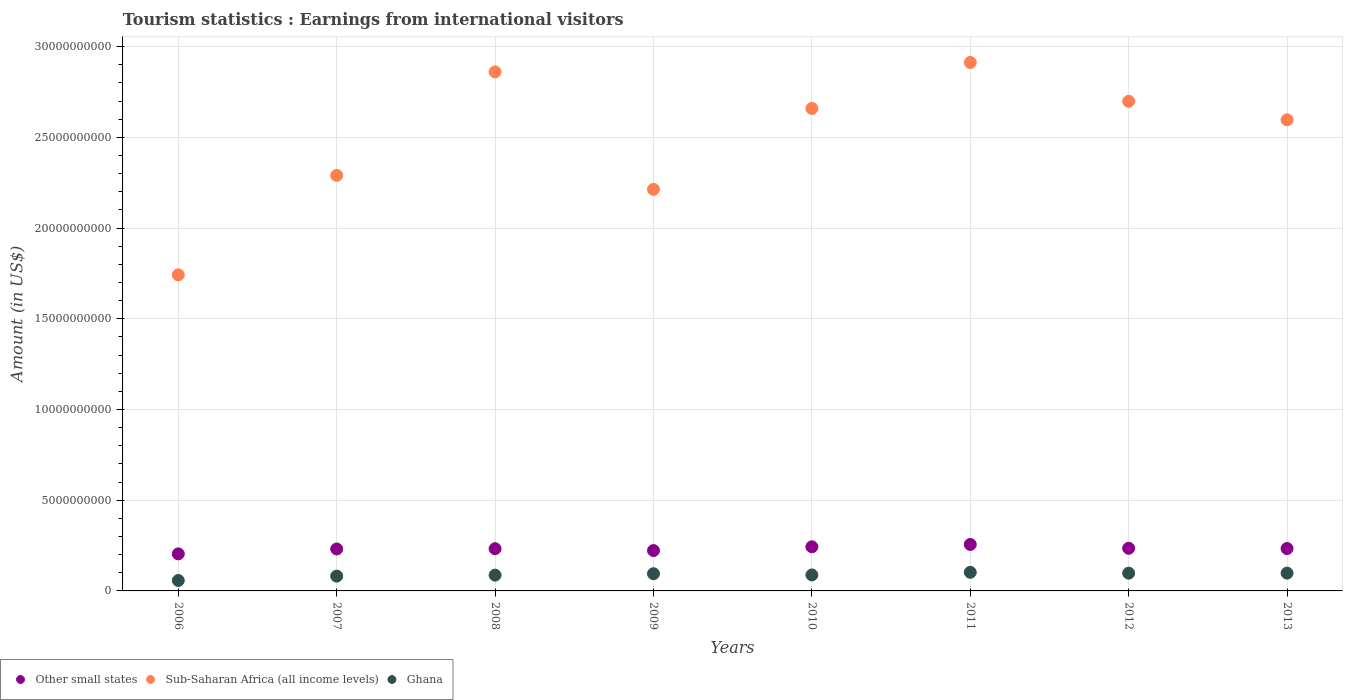How many different coloured dotlines are there?
Offer a very short reply. 3. What is the earnings from international visitors in Other small states in 2008?
Offer a very short reply. 2.33e+09. Across all years, what is the maximum earnings from international visitors in Other small states?
Give a very brief answer. 2.56e+09. Across all years, what is the minimum earnings from international visitors in Other small states?
Give a very brief answer. 2.04e+09. What is the total earnings from international visitors in Ghana in the graph?
Keep it short and to the point. 7.08e+09. What is the difference between the earnings from international visitors in Other small states in 2011 and that in 2013?
Offer a very short reply. 2.23e+08. What is the difference between the earnings from international visitors in Sub-Saharan Africa (all income levels) in 2011 and the earnings from international visitors in Ghana in 2012?
Give a very brief answer. 2.81e+1. What is the average earnings from international visitors in Ghana per year?
Make the answer very short. 8.85e+08. In the year 2012, what is the difference between the earnings from international visitors in Sub-Saharan Africa (all income levels) and earnings from international visitors in Other small states?
Keep it short and to the point. 2.46e+1. What is the ratio of the earnings from international visitors in Sub-Saharan Africa (all income levels) in 2006 to that in 2010?
Your response must be concise. 0.66. Is the difference between the earnings from international visitors in Sub-Saharan Africa (all income levels) in 2007 and 2009 greater than the difference between the earnings from international visitors in Other small states in 2007 and 2009?
Your response must be concise. Yes. What is the difference between the highest and the second highest earnings from international visitors in Other small states?
Provide a short and direct response. 1.28e+08. What is the difference between the highest and the lowest earnings from international visitors in Other small states?
Your response must be concise. 5.18e+08. In how many years, is the earnings from international visitors in Ghana greater than the average earnings from international visitors in Ghana taken over all years?
Your answer should be very brief. 4. Is the sum of the earnings from international visitors in Ghana in 2007 and 2010 greater than the maximum earnings from international visitors in Other small states across all years?
Your answer should be very brief. No. Does the earnings from international visitors in Other small states monotonically increase over the years?
Your answer should be compact. No. Is the earnings from international visitors in Other small states strictly less than the earnings from international visitors in Ghana over the years?
Your answer should be compact. No. How many dotlines are there?
Keep it short and to the point. 3. What is the difference between two consecutive major ticks on the Y-axis?
Your response must be concise. 5.00e+09. Are the values on the major ticks of Y-axis written in scientific E-notation?
Your response must be concise. No. Where does the legend appear in the graph?
Keep it short and to the point. Bottom left. What is the title of the graph?
Offer a terse response. Tourism statistics : Earnings from international visitors. What is the Amount (in US$) in Other small states in 2006?
Provide a short and direct response. 2.04e+09. What is the Amount (in US$) of Sub-Saharan Africa (all income levels) in 2006?
Your answer should be very brief. 1.74e+1. What is the Amount (in US$) in Ghana in 2006?
Your answer should be very brief. 5.75e+08. What is the Amount (in US$) of Other small states in 2007?
Ensure brevity in your answer.  2.31e+09. What is the Amount (in US$) of Sub-Saharan Africa (all income levels) in 2007?
Keep it short and to the point. 2.29e+1. What is the Amount (in US$) of Ghana in 2007?
Make the answer very short. 8.16e+08. What is the Amount (in US$) in Other small states in 2008?
Your response must be concise. 2.33e+09. What is the Amount (in US$) in Sub-Saharan Africa (all income levels) in 2008?
Make the answer very short. 2.86e+1. What is the Amount (in US$) of Ghana in 2008?
Offer a very short reply. 8.70e+08. What is the Amount (in US$) in Other small states in 2009?
Ensure brevity in your answer.  2.23e+09. What is the Amount (in US$) of Sub-Saharan Africa (all income levels) in 2009?
Make the answer very short. 2.21e+1. What is the Amount (in US$) in Ghana in 2009?
Your answer should be compact. 9.48e+08. What is the Amount (in US$) in Other small states in 2010?
Offer a terse response. 2.43e+09. What is the Amount (in US$) of Sub-Saharan Africa (all income levels) in 2010?
Ensure brevity in your answer.  2.66e+1. What is the Amount (in US$) of Ghana in 2010?
Provide a short and direct response. 8.82e+08. What is the Amount (in US$) in Other small states in 2011?
Your answer should be very brief. 2.56e+09. What is the Amount (in US$) in Sub-Saharan Africa (all income levels) in 2011?
Your answer should be compact. 2.91e+1. What is the Amount (in US$) of Ghana in 2011?
Ensure brevity in your answer.  1.03e+09. What is the Amount (in US$) in Other small states in 2012?
Keep it short and to the point. 2.35e+09. What is the Amount (in US$) of Sub-Saharan Africa (all income levels) in 2012?
Your answer should be very brief. 2.70e+1. What is the Amount (in US$) in Ghana in 2012?
Your answer should be compact. 9.79e+08. What is the Amount (in US$) in Other small states in 2013?
Offer a terse response. 2.34e+09. What is the Amount (in US$) in Sub-Saharan Africa (all income levels) in 2013?
Make the answer very short. 2.60e+1. What is the Amount (in US$) in Ghana in 2013?
Provide a succinct answer. 9.82e+08. Across all years, what is the maximum Amount (in US$) in Other small states?
Provide a short and direct response. 2.56e+09. Across all years, what is the maximum Amount (in US$) in Sub-Saharan Africa (all income levels)?
Provide a succinct answer. 2.91e+1. Across all years, what is the maximum Amount (in US$) in Ghana?
Make the answer very short. 1.03e+09. Across all years, what is the minimum Amount (in US$) of Other small states?
Make the answer very short. 2.04e+09. Across all years, what is the minimum Amount (in US$) in Sub-Saharan Africa (all income levels)?
Provide a succinct answer. 1.74e+1. Across all years, what is the minimum Amount (in US$) of Ghana?
Provide a short and direct response. 5.75e+08. What is the total Amount (in US$) in Other small states in the graph?
Your answer should be compact. 1.86e+1. What is the total Amount (in US$) in Sub-Saharan Africa (all income levels) in the graph?
Provide a short and direct response. 2.00e+11. What is the total Amount (in US$) of Ghana in the graph?
Provide a short and direct response. 7.08e+09. What is the difference between the Amount (in US$) in Other small states in 2006 and that in 2007?
Make the answer very short. -2.69e+08. What is the difference between the Amount (in US$) of Sub-Saharan Africa (all income levels) in 2006 and that in 2007?
Your answer should be very brief. -5.48e+09. What is the difference between the Amount (in US$) of Ghana in 2006 and that in 2007?
Provide a short and direct response. -2.41e+08. What is the difference between the Amount (in US$) of Other small states in 2006 and that in 2008?
Offer a very short reply. -2.86e+08. What is the difference between the Amount (in US$) of Sub-Saharan Africa (all income levels) in 2006 and that in 2008?
Give a very brief answer. -1.12e+1. What is the difference between the Amount (in US$) in Ghana in 2006 and that in 2008?
Offer a terse response. -2.95e+08. What is the difference between the Amount (in US$) of Other small states in 2006 and that in 2009?
Offer a terse response. -1.83e+08. What is the difference between the Amount (in US$) in Sub-Saharan Africa (all income levels) in 2006 and that in 2009?
Your answer should be compact. -4.71e+09. What is the difference between the Amount (in US$) in Ghana in 2006 and that in 2009?
Offer a very short reply. -3.73e+08. What is the difference between the Amount (in US$) of Other small states in 2006 and that in 2010?
Make the answer very short. -3.91e+08. What is the difference between the Amount (in US$) in Sub-Saharan Africa (all income levels) in 2006 and that in 2010?
Your response must be concise. -9.17e+09. What is the difference between the Amount (in US$) of Ghana in 2006 and that in 2010?
Make the answer very short. -3.07e+08. What is the difference between the Amount (in US$) in Other small states in 2006 and that in 2011?
Make the answer very short. -5.18e+08. What is the difference between the Amount (in US$) of Sub-Saharan Africa (all income levels) in 2006 and that in 2011?
Keep it short and to the point. -1.17e+1. What is the difference between the Amount (in US$) of Ghana in 2006 and that in 2011?
Ensure brevity in your answer.  -4.51e+08. What is the difference between the Amount (in US$) in Other small states in 2006 and that in 2012?
Your answer should be very brief. -3.08e+08. What is the difference between the Amount (in US$) of Sub-Saharan Africa (all income levels) in 2006 and that in 2012?
Keep it short and to the point. -9.57e+09. What is the difference between the Amount (in US$) in Ghana in 2006 and that in 2012?
Your answer should be compact. -4.04e+08. What is the difference between the Amount (in US$) of Other small states in 2006 and that in 2013?
Give a very brief answer. -2.95e+08. What is the difference between the Amount (in US$) of Sub-Saharan Africa (all income levels) in 2006 and that in 2013?
Ensure brevity in your answer.  -8.54e+09. What is the difference between the Amount (in US$) of Ghana in 2006 and that in 2013?
Provide a short and direct response. -4.07e+08. What is the difference between the Amount (in US$) in Other small states in 2007 and that in 2008?
Make the answer very short. -1.67e+07. What is the difference between the Amount (in US$) in Sub-Saharan Africa (all income levels) in 2007 and that in 2008?
Your answer should be compact. -5.71e+09. What is the difference between the Amount (in US$) in Ghana in 2007 and that in 2008?
Offer a terse response. -5.40e+07. What is the difference between the Amount (in US$) of Other small states in 2007 and that in 2009?
Your answer should be very brief. 8.64e+07. What is the difference between the Amount (in US$) in Sub-Saharan Africa (all income levels) in 2007 and that in 2009?
Keep it short and to the point. 7.64e+08. What is the difference between the Amount (in US$) of Ghana in 2007 and that in 2009?
Offer a very short reply. -1.32e+08. What is the difference between the Amount (in US$) in Other small states in 2007 and that in 2010?
Make the answer very short. -1.21e+08. What is the difference between the Amount (in US$) of Sub-Saharan Africa (all income levels) in 2007 and that in 2010?
Provide a succinct answer. -3.69e+09. What is the difference between the Amount (in US$) of Ghana in 2007 and that in 2010?
Ensure brevity in your answer.  -6.60e+07. What is the difference between the Amount (in US$) in Other small states in 2007 and that in 2011?
Provide a short and direct response. -2.49e+08. What is the difference between the Amount (in US$) in Sub-Saharan Africa (all income levels) in 2007 and that in 2011?
Your answer should be compact. -6.23e+09. What is the difference between the Amount (in US$) of Ghana in 2007 and that in 2011?
Offer a very short reply. -2.10e+08. What is the difference between the Amount (in US$) of Other small states in 2007 and that in 2012?
Your answer should be compact. -3.88e+07. What is the difference between the Amount (in US$) in Sub-Saharan Africa (all income levels) in 2007 and that in 2012?
Make the answer very short. -4.09e+09. What is the difference between the Amount (in US$) in Ghana in 2007 and that in 2012?
Offer a very short reply. -1.63e+08. What is the difference between the Amount (in US$) of Other small states in 2007 and that in 2013?
Keep it short and to the point. -2.57e+07. What is the difference between the Amount (in US$) of Sub-Saharan Africa (all income levels) in 2007 and that in 2013?
Ensure brevity in your answer.  -3.07e+09. What is the difference between the Amount (in US$) of Ghana in 2007 and that in 2013?
Offer a terse response. -1.66e+08. What is the difference between the Amount (in US$) in Other small states in 2008 and that in 2009?
Keep it short and to the point. 1.03e+08. What is the difference between the Amount (in US$) of Sub-Saharan Africa (all income levels) in 2008 and that in 2009?
Provide a succinct answer. 6.47e+09. What is the difference between the Amount (in US$) in Ghana in 2008 and that in 2009?
Your response must be concise. -7.80e+07. What is the difference between the Amount (in US$) in Other small states in 2008 and that in 2010?
Your answer should be compact. -1.05e+08. What is the difference between the Amount (in US$) in Sub-Saharan Africa (all income levels) in 2008 and that in 2010?
Keep it short and to the point. 2.02e+09. What is the difference between the Amount (in US$) in Ghana in 2008 and that in 2010?
Offer a very short reply. -1.20e+07. What is the difference between the Amount (in US$) of Other small states in 2008 and that in 2011?
Offer a terse response. -2.32e+08. What is the difference between the Amount (in US$) in Sub-Saharan Africa (all income levels) in 2008 and that in 2011?
Your answer should be compact. -5.19e+08. What is the difference between the Amount (in US$) in Ghana in 2008 and that in 2011?
Provide a short and direct response. -1.56e+08. What is the difference between the Amount (in US$) of Other small states in 2008 and that in 2012?
Your response must be concise. -2.21e+07. What is the difference between the Amount (in US$) of Sub-Saharan Africa (all income levels) in 2008 and that in 2012?
Provide a short and direct response. 1.62e+09. What is the difference between the Amount (in US$) of Ghana in 2008 and that in 2012?
Your answer should be compact. -1.09e+08. What is the difference between the Amount (in US$) in Other small states in 2008 and that in 2013?
Make the answer very short. -9.03e+06. What is the difference between the Amount (in US$) of Sub-Saharan Africa (all income levels) in 2008 and that in 2013?
Provide a short and direct response. 2.64e+09. What is the difference between the Amount (in US$) of Ghana in 2008 and that in 2013?
Provide a short and direct response. -1.12e+08. What is the difference between the Amount (in US$) of Other small states in 2009 and that in 2010?
Offer a very short reply. -2.08e+08. What is the difference between the Amount (in US$) of Sub-Saharan Africa (all income levels) in 2009 and that in 2010?
Keep it short and to the point. -4.45e+09. What is the difference between the Amount (in US$) of Ghana in 2009 and that in 2010?
Offer a terse response. 6.60e+07. What is the difference between the Amount (in US$) of Other small states in 2009 and that in 2011?
Your response must be concise. -3.35e+08. What is the difference between the Amount (in US$) of Sub-Saharan Africa (all income levels) in 2009 and that in 2011?
Ensure brevity in your answer.  -6.99e+09. What is the difference between the Amount (in US$) of Ghana in 2009 and that in 2011?
Keep it short and to the point. -7.80e+07. What is the difference between the Amount (in US$) of Other small states in 2009 and that in 2012?
Give a very brief answer. -1.25e+08. What is the difference between the Amount (in US$) in Sub-Saharan Africa (all income levels) in 2009 and that in 2012?
Ensure brevity in your answer.  -4.85e+09. What is the difference between the Amount (in US$) in Ghana in 2009 and that in 2012?
Your answer should be very brief. -3.10e+07. What is the difference between the Amount (in US$) of Other small states in 2009 and that in 2013?
Provide a succinct answer. -1.12e+08. What is the difference between the Amount (in US$) of Sub-Saharan Africa (all income levels) in 2009 and that in 2013?
Give a very brief answer. -3.83e+09. What is the difference between the Amount (in US$) of Ghana in 2009 and that in 2013?
Your answer should be very brief. -3.40e+07. What is the difference between the Amount (in US$) of Other small states in 2010 and that in 2011?
Your answer should be compact. -1.28e+08. What is the difference between the Amount (in US$) in Sub-Saharan Africa (all income levels) in 2010 and that in 2011?
Offer a very short reply. -2.54e+09. What is the difference between the Amount (in US$) in Ghana in 2010 and that in 2011?
Give a very brief answer. -1.44e+08. What is the difference between the Amount (in US$) of Other small states in 2010 and that in 2012?
Offer a terse response. 8.26e+07. What is the difference between the Amount (in US$) in Sub-Saharan Africa (all income levels) in 2010 and that in 2012?
Offer a very short reply. -3.97e+08. What is the difference between the Amount (in US$) of Ghana in 2010 and that in 2012?
Provide a short and direct response. -9.70e+07. What is the difference between the Amount (in US$) in Other small states in 2010 and that in 2013?
Keep it short and to the point. 9.57e+07. What is the difference between the Amount (in US$) of Sub-Saharan Africa (all income levels) in 2010 and that in 2013?
Provide a succinct answer. 6.25e+08. What is the difference between the Amount (in US$) in Ghana in 2010 and that in 2013?
Provide a short and direct response. -1.00e+08. What is the difference between the Amount (in US$) of Other small states in 2011 and that in 2012?
Provide a succinct answer. 2.10e+08. What is the difference between the Amount (in US$) in Sub-Saharan Africa (all income levels) in 2011 and that in 2012?
Your response must be concise. 2.14e+09. What is the difference between the Amount (in US$) of Ghana in 2011 and that in 2012?
Your answer should be very brief. 4.70e+07. What is the difference between the Amount (in US$) in Other small states in 2011 and that in 2013?
Offer a very short reply. 2.23e+08. What is the difference between the Amount (in US$) in Sub-Saharan Africa (all income levels) in 2011 and that in 2013?
Offer a very short reply. 3.16e+09. What is the difference between the Amount (in US$) in Ghana in 2011 and that in 2013?
Your response must be concise. 4.40e+07. What is the difference between the Amount (in US$) in Other small states in 2012 and that in 2013?
Offer a terse response. 1.31e+07. What is the difference between the Amount (in US$) of Sub-Saharan Africa (all income levels) in 2012 and that in 2013?
Give a very brief answer. 1.02e+09. What is the difference between the Amount (in US$) in Ghana in 2012 and that in 2013?
Your answer should be compact. -3.00e+06. What is the difference between the Amount (in US$) of Other small states in 2006 and the Amount (in US$) of Sub-Saharan Africa (all income levels) in 2007?
Offer a very short reply. -2.09e+1. What is the difference between the Amount (in US$) of Other small states in 2006 and the Amount (in US$) of Ghana in 2007?
Provide a short and direct response. 1.23e+09. What is the difference between the Amount (in US$) in Sub-Saharan Africa (all income levels) in 2006 and the Amount (in US$) in Ghana in 2007?
Offer a very short reply. 1.66e+1. What is the difference between the Amount (in US$) of Other small states in 2006 and the Amount (in US$) of Sub-Saharan Africa (all income levels) in 2008?
Your response must be concise. -2.66e+1. What is the difference between the Amount (in US$) of Other small states in 2006 and the Amount (in US$) of Ghana in 2008?
Give a very brief answer. 1.17e+09. What is the difference between the Amount (in US$) in Sub-Saharan Africa (all income levels) in 2006 and the Amount (in US$) in Ghana in 2008?
Your response must be concise. 1.66e+1. What is the difference between the Amount (in US$) in Other small states in 2006 and the Amount (in US$) in Sub-Saharan Africa (all income levels) in 2009?
Your response must be concise. -2.01e+1. What is the difference between the Amount (in US$) in Other small states in 2006 and the Amount (in US$) in Ghana in 2009?
Make the answer very short. 1.09e+09. What is the difference between the Amount (in US$) of Sub-Saharan Africa (all income levels) in 2006 and the Amount (in US$) of Ghana in 2009?
Make the answer very short. 1.65e+1. What is the difference between the Amount (in US$) of Other small states in 2006 and the Amount (in US$) of Sub-Saharan Africa (all income levels) in 2010?
Your answer should be very brief. -2.45e+1. What is the difference between the Amount (in US$) in Other small states in 2006 and the Amount (in US$) in Ghana in 2010?
Your answer should be compact. 1.16e+09. What is the difference between the Amount (in US$) of Sub-Saharan Africa (all income levels) in 2006 and the Amount (in US$) of Ghana in 2010?
Your response must be concise. 1.65e+1. What is the difference between the Amount (in US$) of Other small states in 2006 and the Amount (in US$) of Sub-Saharan Africa (all income levels) in 2011?
Ensure brevity in your answer.  -2.71e+1. What is the difference between the Amount (in US$) in Other small states in 2006 and the Amount (in US$) in Ghana in 2011?
Your answer should be very brief. 1.02e+09. What is the difference between the Amount (in US$) of Sub-Saharan Africa (all income levels) in 2006 and the Amount (in US$) of Ghana in 2011?
Make the answer very short. 1.64e+1. What is the difference between the Amount (in US$) of Other small states in 2006 and the Amount (in US$) of Sub-Saharan Africa (all income levels) in 2012?
Give a very brief answer. -2.49e+1. What is the difference between the Amount (in US$) of Other small states in 2006 and the Amount (in US$) of Ghana in 2012?
Ensure brevity in your answer.  1.06e+09. What is the difference between the Amount (in US$) in Sub-Saharan Africa (all income levels) in 2006 and the Amount (in US$) in Ghana in 2012?
Make the answer very short. 1.64e+1. What is the difference between the Amount (in US$) of Other small states in 2006 and the Amount (in US$) of Sub-Saharan Africa (all income levels) in 2013?
Your response must be concise. -2.39e+1. What is the difference between the Amount (in US$) in Other small states in 2006 and the Amount (in US$) in Ghana in 2013?
Your response must be concise. 1.06e+09. What is the difference between the Amount (in US$) of Sub-Saharan Africa (all income levels) in 2006 and the Amount (in US$) of Ghana in 2013?
Your answer should be compact. 1.64e+1. What is the difference between the Amount (in US$) of Other small states in 2007 and the Amount (in US$) of Sub-Saharan Africa (all income levels) in 2008?
Make the answer very short. -2.63e+1. What is the difference between the Amount (in US$) of Other small states in 2007 and the Amount (in US$) of Ghana in 2008?
Your answer should be compact. 1.44e+09. What is the difference between the Amount (in US$) of Sub-Saharan Africa (all income levels) in 2007 and the Amount (in US$) of Ghana in 2008?
Offer a very short reply. 2.20e+1. What is the difference between the Amount (in US$) in Other small states in 2007 and the Amount (in US$) in Sub-Saharan Africa (all income levels) in 2009?
Your answer should be very brief. -1.98e+1. What is the difference between the Amount (in US$) in Other small states in 2007 and the Amount (in US$) in Ghana in 2009?
Your answer should be very brief. 1.36e+09. What is the difference between the Amount (in US$) in Sub-Saharan Africa (all income levels) in 2007 and the Amount (in US$) in Ghana in 2009?
Offer a very short reply. 2.20e+1. What is the difference between the Amount (in US$) in Other small states in 2007 and the Amount (in US$) in Sub-Saharan Africa (all income levels) in 2010?
Your answer should be compact. -2.43e+1. What is the difference between the Amount (in US$) of Other small states in 2007 and the Amount (in US$) of Ghana in 2010?
Offer a very short reply. 1.43e+09. What is the difference between the Amount (in US$) of Sub-Saharan Africa (all income levels) in 2007 and the Amount (in US$) of Ghana in 2010?
Provide a short and direct response. 2.20e+1. What is the difference between the Amount (in US$) of Other small states in 2007 and the Amount (in US$) of Sub-Saharan Africa (all income levels) in 2011?
Provide a short and direct response. -2.68e+1. What is the difference between the Amount (in US$) in Other small states in 2007 and the Amount (in US$) in Ghana in 2011?
Your answer should be compact. 1.29e+09. What is the difference between the Amount (in US$) in Sub-Saharan Africa (all income levels) in 2007 and the Amount (in US$) in Ghana in 2011?
Your response must be concise. 2.19e+1. What is the difference between the Amount (in US$) of Other small states in 2007 and the Amount (in US$) of Sub-Saharan Africa (all income levels) in 2012?
Provide a short and direct response. -2.47e+1. What is the difference between the Amount (in US$) in Other small states in 2007 and the Amount (in US$) in Ghana in 2012?
Offer a very short reply. 1.33e+09. What is the difference between the Amount (in US$) of Sub-Saharan Africa (all income levels) in 2007 and the Amount (in US$) of Ghana in 2012?
Offer a terse response. 2.19e+1. What is the difference between the Amount (in US$) of Other small states in 2007 and the Amount (in US$) of Sub-Saharan Africa (all income levels) in 2013?
Your answer should be compact. -2.37e+1. What is the difference between the Amount (in US$) in Other small states in 2007 and the Amount (in US$) in Ghana in 2013?
Keep it short and to the point. 1.33e+09. What is the difference between the Amount (in US$) of Sub-Saharan Africa (all income levels) in 2007 and the Amount (in US$) of Ghana in 2013?
Make the answer very short. 2.19e+1. What is the difference between the Amount (in US$) in Other small states in 2008 and the Amount (in US$) in Sub-Saharan Africa (all income levels) in 2009?
Provide a succinct answer. -1.98e+1. What is the difference between the Amount (in US$) in Other small states in 2008 and the Amount (in US$) in Ghana in 2009?
Make the answer very short. 1.38e+09. What is the difference between the Amount (in US$) in Sub-Saharan Africa (all income levels) in 2008 and the Amount (in US$) in Ghana in 2009?
Your response must be concise. 2.77e+1. What is the difference between the Amount (in US$) of Other small states in 2008 and the Amount (in US$) of Sub-Saharan Africa (all income levels) in 2010?
Give a very brief answer. -2.43e+1. What is the difference between the Amount (in US$) of Other small states in 2008 and the Amount (in US$) of Ghana in 2010?
Make the answer very short. 1.45e+09. What is the difference between the Amount (in US$) of Sub-Saharan Africa (all income levels) in 2008 and the Amount (in US$) of Ghana in 2010?
Make the answer very short. 2.77e+1. What is the difference between the Amount (in US$) in Other small states in 2008 and the Amount (in US$) in Sub-Saharan Africa (all income levels) in 2011?
Offer a very short reply. -2.68e+1. What is the difference between the Amount (in US$) of Other small states in 2008 and the Amount (in US$) of Ghana in 2011?
Provide a short and direct response. 1.30e+09. What is the difference between the Amount (in US$) in Sub-Saharan Africa (all income levels) in 2008 and the Amount (in US$) in Ghana in 2011?
Provide a succinct answer. 2.76e+1. What is the difference between the Amount (in US$) of Other small states in 2008 and the Amount (in US$) of Sub-Saharan Africa (all income levels) in 2012?
Offer a very short reply. -2.47e+1. What is the difference between the Amount (in US$) in Other small states in 2008 and the Amount (in US$) in Ghana in 2012?
Your response must be concise. 1.35e+09. What is the difference between the Amount (in US$) of Sub-Saharan Africa (all income levels) in 2008 and the Amount (in US$) of Ghana in 2012?
Your answer should be compact. 2.76e+1. What is the difference between the Amount (in US$) in Other small states in 2008 and the Amount (in US$) in Sub-Saharan Africa (all income levels) in 2013?
Offer a terse response. -2.36e+1. What is the difference between the Amount (in US$) of Other small states in 2008 and the Amount (in US$) of Ghana in 2013?
Provide a short and direct response. 1.35e+09. What is the difference between the Amount (in US$) of Sub-Saharan Africa (all income levels) in 2008 and the Amount (in US$) of Ghana in 2013?
Your response must be concise. 2.76e+1. What is the difference between the Amount (in US$) of Other small states in 2009 and the Amount (in US$) of Sub-Saharan Africa (all income levels) in 2010?
Your answer should be compact. -2.44e+1. What is the difference between the Amount (in US$) of Other small states in 2009 and the Amount (in US$) of Ghana in 2010?
Make the answer very short. 1.34e+09. What is the difference between the Amount (in US$) in Sub-Saharan Africa (all income levels) in 2009 and the Amount (in US$) in Ghana in 2010?
Provide a short and direct response. 2.13e+1. What is the difference between the Amount (in US$) in Other small states in 2009 and the Amount (in US$) in Sub-Saharan Africa (all income levels) in 2011?
Keep it short and to the point. -2.69e+1. What is the difference between the Amount (in US$) of Other small states in 2009 and the Amount (in US$) of Ghana in 2011?
Make the answer very short. 1.20e+09. What is the difference between the Amount (in US$) in Sub-Saharan Africa (all income levels) in 2009 and the Amount (in US$) in Ghana in 2011?
Keep it short and to the point. 2.11e+1. What is the difference between the Amount (in US$) of Other small states in 2009 and the Amount (in US$) of Sub-Saharan Africa (all income levels) in 2012?
Your answer should be compact. -2.48e+1. What is the difference between the Amount (in US$) in Other small states in 2009 and the Amount (in US$) in Ghana in 2012?
Give a very brief answer. 1.25e+09. What is the difference between the Amount (in US$) of Sub-Saharan Africa (all income levels) in 2009 and the Amount (in US$) of Ghana in 2012?
Your response must be concise. 2.12e+1. What is the difference between the Amount (in US$) in Other small states in 2009 and the Amount (in US$) in Sub-Saharan Africa (all income levels) in 2013?
Provide a short and direct response. -2.37e+1. What is the difference between the Amount (in US$) in Other small states in 2009 and the Amount (in US$) in Ghana in 2013?
Give a very brief answer. 1.24e+09. What is the difference between the Amount (in US$) of Sub-Saharan Africa (all income levels) in 2009 and the Amount (in US$) of Ghana in 2013?
Your response must be concise. 2.12e+1. What is the difference between the Amount (in US$) in Other small states in 2010 and the Amount (in US$) in Sub-Saharan Africa (all income levels) in 2011?
Offer a terse response. -2.67e+1. What is the difference between the Amount (in US$) in Other small states in 2010 and the Amount (in US$) in Ghana in 2011?
Give a very brief answer. 1.41e+09. What is the difference between the Amount (in US$) in Sub-Saharan Africa (all income levels) in 2010 and the Amount (in US$) in Ghana in 2011?
Give a very brief answer. 2.56e+1. What is the difference between the Amount (in US$) in Other small states in 2010 and the Amount (in US$) in Sub-Saharan Africa (all income levels) in 2012?
Keep it short and to the point. -2.46e+1. What is the difference between the Amount (in US$) in Other small states in 2010 and the Amount (in US$) in Ghana in 2012?
Offer a terse response. 1.45e+09. What is the difference between the Amount (in US$) of Sub-Saharan Africa (all income levels) in 2010 and the Amount (in US$) of Ghana in 2012?
Provide a short and direct response. 2.56e+1. What is the difference between the Amount (in US$) of Other small states in 2010 and the Amount (in US$) of Sub-Saharan Africa (all income levels) in 2013?
Offer a terse response. -2.35e+1. What is the difference between the Amount (in US$) in Other small states in 2010 and the Amount (in US$) in Ghana in 2013?
Your response must be concise. 1.45e+09. What is the difference between the Amount (in US$) of Sub-Saharan Africa (all income levels) in 2010 and the Amount (in US$) of Ghana in 2013?
Provide a short and direct response. 2.56e+1. What is the difference between the Amount (in US$) of Other small states in 2011 and the Amount (in US$) of Sub-Saharan Africa (all income levels) in 2012?
Offer a terse response. -2.44e+1. What is the difference between the Amount (in US$) in Other small states in 2011 and the Amount (in US$) in Ghana in 2012?
Your response must be concise. 1.58e+09. What is the difference between the Amount (in US$) in Sub-Saharan Africa (all income levels) in 2011 and the Amount (in US$) in Ghana in 2012?
Offer a terse response. 2.81e+1. What is the difference between the Amount (in US$) in Other small states in 2011 and the Amount (in US$) in Sub-Saharan Africa (all income levels) in 2013?
Your answer should be very brief. -2.34e+1. What is the difference between the Amount (in US$) in Other small states in 2011 and the Amount (in US$) in Ghana in 2013?
Your answer should be very brief. 1.58e+09. What is the difference between the Amount (in US$) in Sub-Saharan Africa (all income levels) in 2011 and the Amount (in US$) in Ghana in 2013?
Offer a terse response. 2.81e+1. What is the difference between the Amount (in US$) of Other small states in 2012 and the Amount (in US$) of Sub-Saharan Africa (all income levels) in 2013?
Provide a short and direct response. -2.36e+1. What is the difference between the Amount (in US$) in Other small states in 2012 and the Amount (in US$) in Ghana in 2013?
Offer a terse response. 1.37e+09. What is the difference between the Amount (in US$) of Sub-Saharan Africa (all income levels) in 2012 and the Amount (in US$) of Ghana in 2013?
Provide a succinct answer. 2.60e+1. What is the average Amount (in US$) in Other small states per year?
Offer a terse response. 2.32e+09. What is the average Amount (in US$) of Sub-Saharan Africa (all income levels) per year?
Your response must be concise. 2.50e+1. What is the average Amount (in US$) of Ghana per year?
Offer a terse response. 8.85e+08. In the year 2006, what is the difference between the Amount (in US$) in Other small states and Amount (in US$) in Sub-Saharan Africa (all income levels)?
Your answer should be very brief. -1.54e+1. In the year 2006, what is the difference between the Amount (in US$) in Other small states and Amount (in US$) in Ghana?
Offer a very short reply. 1.47e+09. In the year 2006, what is the difference between the Amount (in US$) of Sub-Saharan Africa (all income levels) and Amount (in US$) of Ghana?
Offer a very short reply. 1.68e+1. In the year 2007, what is the difference between the Amount (in US$) in Other small states and Amount (in US$) in Sub-Saharan Africa (all income levels)?
Keep it short and to the point. -2.06e+1. In the year 2007, what is the difference between the Amount (in US$) in Other small states and Amount (in US$) in Ghana?
Your answer should be compact. 1.50e+09. In the year 2007, what is the difference between the Amount (in US$) of Sub-Saharan Africa (all income levels) and Amount (in US$) of Ghana?
Provide a short and direct response. 2.21e+1. In the year 2008, what is the difference between the Amount (in US$) of Other small states and Amount (in US$) of Sub-Saharan Africa (all income levels)?
Keep it short and to the point. -2.63e+1. In the year 2008, what is the difference between the Amount (in US$) of Other small states and Amount (in US$) of Ghana?
Ensure brevity in your answer.  1.46e+09. In the year 2008, what is the difference between the Amount (in US$) in Sub-Saharan Africa (all income levels) and Amount (in US$) in Ghana?
Your answer should be very brief. 2.77e+1. In the year 2009, what is the difference between the Amount (in US$) of Other small states and Amount (in US$) of Sub-Saharan Africa (all income levels)?
Give a very brief answer. -1.99e+1. In the year 2009, what is the difference between the Amount (in US$) in Other small states and Amount (in US$) in Ghana?
Ensure brevity in your answer.  1.28e+09. In the year 2009, what is the difference between the Amount (in US$) of Sub-Saharan Africa (all income levels) and Amount (in US$) of Ghana?
Make the answer very short. 2.12e+1. In the year 2010, what is the difference between the Amount (in US$) in Other small states and Amount (in US$) in Sub-Saharan Africa (all income levels)?
Your answer should be very brief. -2.42e+1. In the year 2010, what is the difference between the Amount (in US$) in Other small states and Amount (in US$) in Ghana?
Give a very brief answer. 1.55e+09. In the year 2010, what is the difference between the Amount (in US$) of Sub-Saharan Africa (all income levels) and Amount (in US$) of Ghana?
Offer a very short reply. 2.57e+1. In the year 2011, what is the difference between the Amount (in US$) in Other small states and Amount (in US$) in Sub-Saharan Africa (all income levels)?
Ensure brevity in your answer.  -2.66e+1. In the year 2011, what is the difference between the Amount (in US$) in Other small states and Amount (in US$) in Ghana?
Your answer should be very brief. 1.53e+09. In the year 2011, what is the difference between the Amount (in US$) of Sub-Saharan Africa (all income levels) and Amount (in US$) of Ghana?
Offer a very short reply. 2.81e+1. In the year 2012, what is the difference between the Amount (in US$) in Other small states and Amount (in US$) in Sub-Saharan Africa (all income levels)?
Ensure brevity in your answer.  -2.46e+1. In the year 2012, what is the difference between the Amount (in US$) of Other small states and Amount (in US$) of Ghana?
Give a very brief answer. 1.37e+09. In the year 2012, what is the difference between the Amount (in US$) in Sub-Saharan Africa (all income levels) and Amount (in US$) in Ghana?
Your answer should be compact. 2.60e+1. In the year 2013, what is the difference between the Amount (in US$) in Other small states and Amount (in US$) in Sub-Saharan Africa (all income levels)?
Provide a short and direct response. -2.36e+1. In the year 2013, what is the difference between the Amount (in US$) of Other small states and Amount (in US$) of Ghana?
Ensure brevity in your answer.  1.36e+09. In the year 2013, what is the difference between the Amount (in US$) in Sub-Saharan Africa (all income levels) and Amount (in US$) in Ghana?
Your answer should be very brief. 2.50e+1. What is the ratio of the Amount (in US$) in Other small states in 2006 to that in 2007?
Ensure brevity in your answer.  0.88. What is the ratio of the Amount (in US$) of Sub-Saharan Africa (all income levels) in 2006 to that in 2007?
Ensure brevity in your answer.  0.76. What is the ratio of the Amount (in US$) of Ghana in 2006 to that in 2007?
Provide a succinct answer. 0.7. What is the ratio of the Amount (in US$) of Other small states in 2006 to that in 2008?
Ensure brevity in your answer.  0.88. What is the ratio of the Amount (in US$) in Sub-Saharan Africa (all income levels) in 2006 to that in 2008?
Make the answer very short. 0.61. What is the ratio of the Amount (in US$) in Ghana in 2006 to that in 2008?
Ensure brevity in your answer.  0.66. What is the ratio of the Amount (in US$) in Other small states in 2006 to that in 2009?
Keep it short and to the point. 0.92. What is the ratio of the Amount (in US$) of Sub-Saharan Africa (all income levels) in 2006 to that in 2009?
Ensure brevity in your answer.  0.79. What is the ratio of the Amount (in US$) of Ghana in 2006 to that in 2009?
Offer a terse response. 0.61. What is the ratio of the Amount (in US$) in Other small states in 2006 to that in 2010?
Ensure brevity in your answer.  0.84. What is the ratio of the Amount (in US$) of Sub-Saharan Africa (all income levels) in 2006 to that in 2010?
Your answer should be very brief. 0.66. What is the ratio of the Amount (in US$) of Ghana in 2006 to that in 2010?
Provide a short and direct response. 0.65. What is the ratio of the Amount (in US$) of Other small states in 2006 to that in 2011?
Keep it short and to the point. 0.8. What is the ratio of the Amount (in US$) of Sub-Saharan Africa (all income levels) in 2006 to that in 2011?
Your response must be concise. 0.6. What is the ratio of the Amount (in US$) of Ghana in 2006 to that in 2011?
Provide a short and direct response. 0.56. What is the ratio of the Amount (in US$) of Other small states in 2006 to that in 2012?
Provide a short and direct response. 0.87. What is the ratio of the Amount (in US$) of Sub-Saharan Africa (all income levels) in 2006 to that in 2012?
Provide a short and direct response. 0.65. What is the ratio of the Amount (in US$) of Ghana in 2006 to that in 2012?
Offer a very short reply. 0.59. What is the ratio of the Amount (in US$) in Other small states in 2006 to that in 2013?
Offer a very short reply. 0.87. What is the ratio of the Amount (in US$) of Sub-Saharan Africa (all income levels) in 2006 to that in 2013?
Provide a succinct answer. 0.67. What is the ratio of the Amount (in US$) in Ghana in 2006 to that in 2013?
Offer a very short reply. 0.59. What is the ratio of the Amount (in US$) of Sub-Saharan Africa (all income levels) in 2007 to that in 2008?
Your response must be concise. 0.8. What is the ratio of the Amount (in US$) in Ghana in 2007 to that in 2008?
Give a very brief answer. 0.94. What is the ratio of the Amount (in US$) of Other small states in 2007 to that in 2009?
Give a very brief answer. 1.04. What is the ratio of the Amount (in US$) of Sub-Saharan Africa (all income levels) in 2007 to that in 2009?
Offer a terse response. 1.03. What is the ratio of the Amount (in US$) of Ghana in 2007 to that in 2009?
Ensure brevity in your answer.  0.86. What is the ratio of the Amount (in US$) of Other small states in 2007 to that in 2010?
Offer a very short reply. 0.95. What is the ratio of the Amount (in US$) of Sub-Saharan Africa (all income levels) in 2007 to that in 2010?
Provide a succinct answer. 0.86. What is the ratio of the Amount (in US$) in Ghana in 2007 to that in 2010?
Offer a very short reply. 0.93. What is the ratio of the Amount (in US$) in Other small states in 2007 to that in 2011?
Offer a terse response. 0.9. What is the ratio of the Amount (in US$) of Sub-Saharan Africa (all income levels) in 2007 to that in 2011?
Make the answer very short. 0.79. What is the ratio of the Amount (in US$) of Ghana in 2007 to that in 2011?
Offer a very short reply. 0.8. What is the ratio of the Amount (in US$) of Other small states in 2007 to that in 2012?
Ensure brevity in your answer.  0.98. What is the ratio of the Amount (in US$) in Sub-Saharan Africa (all income levels) in 2007 to that in 2012?
Ensure brevity in your answer.  0.85. What is the ratio of the Amount (in US$) in Ghana in 2007 to that in 2012?
Make the answer very short. 0.83. What is the ratio of the Amount (in US$) of Other small states in 2007 to that in 2013?
Provide a succinct answer. 0.99. What is the ratio of the Amount (in US$) of Sub-Saharan Africa (all income levels) in 2007 to that in 2013?
Keep it short and to the point. 0.88. What is the ratio of the Amount (in US$) of Ghana in 2007 to that in 2013?
Provide a succinct answer. 0.83. What is the ratio of the Amount (in US$) in Other small states in 2008 to that in 2009?
Your answer should be very brief. 1.05. What is the ratio of the Amount (in US$) of Sub-Saharan Africa (all income levels) in 2008 to that in 2009?
Offer a terse response. 1.29. What is the ratio of the Amount (in US$) of Ghana in 2008 to that in 2009?
Keep it short and to the point. 0.92. What is the ratio of the Amount (in US$) of Sub-Saharan Africa (all income levels) in 2008 to that in 2010?
Keep it short and to the point. 1.08. What is the ratio of the Amount (in US$) of Ghana in 2008 to that in 2010?
Keep it short and to the point. 0.99. What is the ratio of the Amount (in US$) in Other small states in 2008 to that in 2011?
Make the answer very short. 0.91. What is the ratio of the Amount (in US$) of Sub-Saharan Africa (all income levels) in 2008 to that in 2011?
Ensure brevity in your answer.  0.98. What is the ratio of the Amount (in US$) of Ghana in 2008 to that in 2011?
Offer a very short reply. 0.85. What is the ratio of the Amount (in US$) in Other small states in 2008 to that in 2012?
Your answer should be compact. 0.99. What is the ratio of the Amount (in US$) of Sub-Saharan Africa (all income levels) in 2008 to that in 2012?
Your response must be concise. 1.06. What is the ratio of the Amount (in US$) of Ghana in 2008 to that in 2012?
Your answer should be very brief. 0.89. What is the ratio of the Amount (in US$) of Sub-Saharan Africa (all income levels) in 2008 to that in 2013?
Your answer should be compact. 1.1. What is the ratio of the Amount (in US$) in Ghana in 2008 to that in 2013?
Your answer should be very brief. 0.89. What is the ratio of the Amount (in US$) of Other small states in 2009 to that in 2010?
Provide a short and direct response. 0.91. What is the ratio of the Amount (in US$) in Sub-Saharan Africa (all income levels) in 2009 to that in 2010?
Your response must be concise. 0.83. What is the ratio of the Amount (in US$) of Ghana in 2009 to that in 2010?
Your response must be concise. 1.07. What is the ratio of the Amount (in US$) in Other small states in 2009 to that in 2011?
Give a very brief answer. 0.87. What is the ratio of the Amount (in US$) in Sub-Saharan Africa (all income levels) in 2009 to that in 2011?
Give a very brief answer. 0.76. What is the ratio of the Amount (in US$) in Ghana in 2009 to that in 2011?
Keep it short and to the point. 0.92. What is the ratio of the Amount (in US$) of Other small states in 2009 to that in 2012?
Give a very brief answer. 0.95. What is the ratio of the Amount (in US$) of Sub-Saharan Africa (all income levels) in 2009 to that in 2012?
Keep it short and to the point. 0.82. What is the ratio of the Amount (in US$) of Ghana in 2009 to that in 2012?
Make the answer very short. 0.97. What is the ratio of the Amount (in US$) in Other small states in 2009 to that in 2013?
Make the answer very short. 0.95. What is the ratio of the Amount (in US$) of Sub-Saharan Africa (all income levels) in 2009 to that in 2013?
Your answer should be very brief. 0.85. What is the ratio of the Amount (in US$) in Ghana in 2009 to that in 2013?
Give a very brief answer. 0.97. What is the ratio of the Amount (in US$) in Other small states in 2010 to that in 2011?
Ensure brevity in your answer.  0.95. What is the ratio of the Amount (in US$) in Sub-Saharan Africa (all income levels) in 2010 to that in 2011?
Offer a very short reply. 0.91. What is the ratio of the Amount (in US$) in Ghana in 2010 to that in 2011?
Your answer should be compact. 0.86. What is the ratio of the Amount (in US$) in Other small states in 2010 to that in 2012?
Your answer should be very brief. 1.04. What is the ratio of the Amount (in US$) in Sub-Saharan Africa (all income levels) in 2010 to that in 2012?
Ensure brevity in your answer.  0.99. What is the ratio of the Amount (in US$) of Ghana in 2010 to that in 2012?
Provide a short and direct response. 0.9. What is the ratio of the Amount (in US$) of Other small states in 2010 to that in 2013?
Make the answer very short. 1.04. What is the ratio of the Amount (in US$) in Sub-Saharan Africa (all income levels) in 2010 to that in 2013?
Provide a short and direct response. 1.02. What is the ratio of the Amount (in US$) of Ghana in 2010 to that in 2013?
Your answer should be very brief. 0.9. What is the ratio of the Amount (in US$) of Other small states in 2011 to that in 2012?
Your answer should be compact. 1.09. What is the ratio of the Amount (in US$) in Sub-Saharan Africa (all income levels) in 2011 to that in 2012?
Keep it short and to the point. 1.08. What is the ratio of the Amount (in US$) in Ghana in 2011 to that in 2012?
Offer a very short reply. 1.05. What is the ratio of the Amount (in US$) in Other small states in 2011 to that in 2013?
Your answer should be very brief. 1.1. What is the ratio of the Amount (in US$) of Sub-Saharan Africa (all income levels) in 2011 to that in 2013?
Your response must be concise. 1.12. What is the ratio of the Amount (in US$) in Ghana in 2011 to that in 2013?
Your answer should be compact. 1.04. What is the ratio of the Amount (in US$) of Other small states in 2012 to that in 2013?
Provide a short and direct response. 1.01. What is the ratio of the Amount (in US$) of Sub-Saharan Africa (all income levels) in 2012 to that in 2013?
Make the answer very short. 1.04. What is the difference between the highest and the second highest Amount (in US$) in Other small states?
Ensure brevity in your answer.  1.28e+08. What is the difference between the highest and the second highest Amount (in US$) in Sub-Saharan Africa (all income levels)?
Provide a succinct answer. 5.19e+08. What is the difference between the highest and the second highest Amount (in US$) in Ghana?
Give a very brief answer. 4.40e+07. What is the difference between the highest and the lowest Amount (in US$) of Other small states?
Your answer should be very brief. 5.18e+08. What is the difference between the highest and the lowest Amount (in US$) of Sub-Saharan Africa (all income levels)?
Ensure brevity in your answer.  1.17e+1. What is the difference between the highest and the lowest Amount (in US$) of Ghana?
Give a very brief answer. 4.51e+08. 